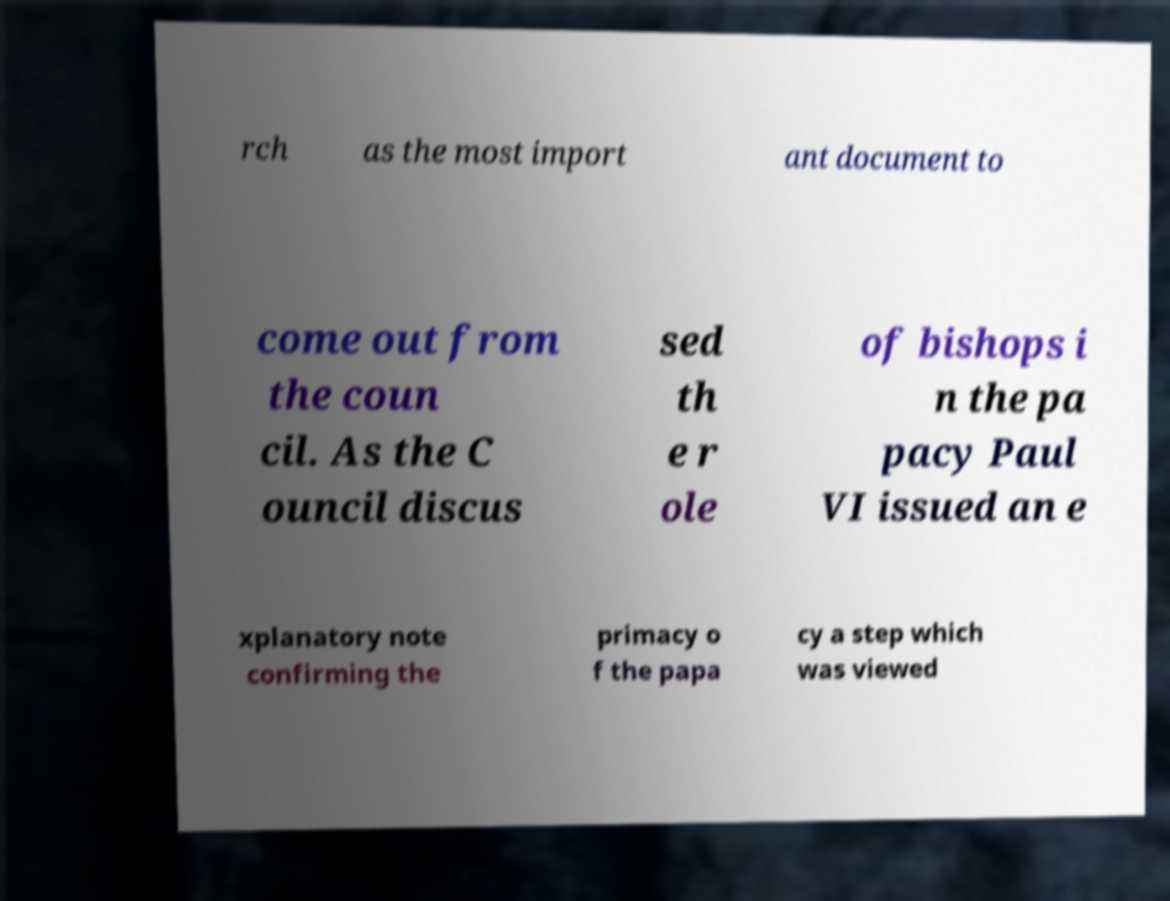Can you read and provide the text displayed in the image?This photo seems to have some interesting text. Can you extract and type it out for me? rch as the most import ant document to come out from the coun cil. As the C ouncil discus sed th e r ole of bishops i n the pa pacy Paul VI issued an e xplanatory note confirming the primacy o f the papa cy a step which was viewed 